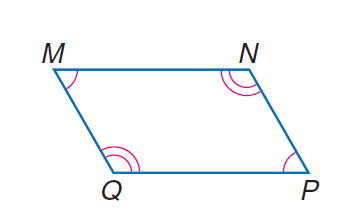Answer the mathemtical geometry problem and directly provide the correct option letter.
Question: parallelogram M N P Q with m \angle M = 10 x and m \angle N = 20 x, find \angle N.
Choices: A: 30 B: 45 C: 60 D: 120 D 